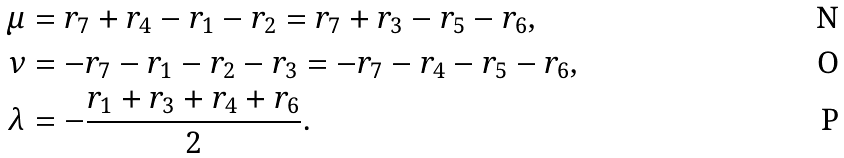<formula> <loc_0><loc_0><loc_500><loc_500>\mu & = r _ { 7 } + r _ { 4 } - r _ { 1 } - r _ { 2 } = r _ { 7 } + r _ { 3 } - r _ { 5 } - r _ { 6 } , \\ \nu & = - r _ { 7 } - r _ { 1 } - r _ { 2 } - r _ { 3 } = - r _ { 7 } - r _ { 4 } - r _ { 5 } - r _ { 6 } , \\ \lambda & = - \frac { r _ { 1 } + r _ { 3 } + r _ { 4 } + r _ { 6 } } { 2 } .</formula> 